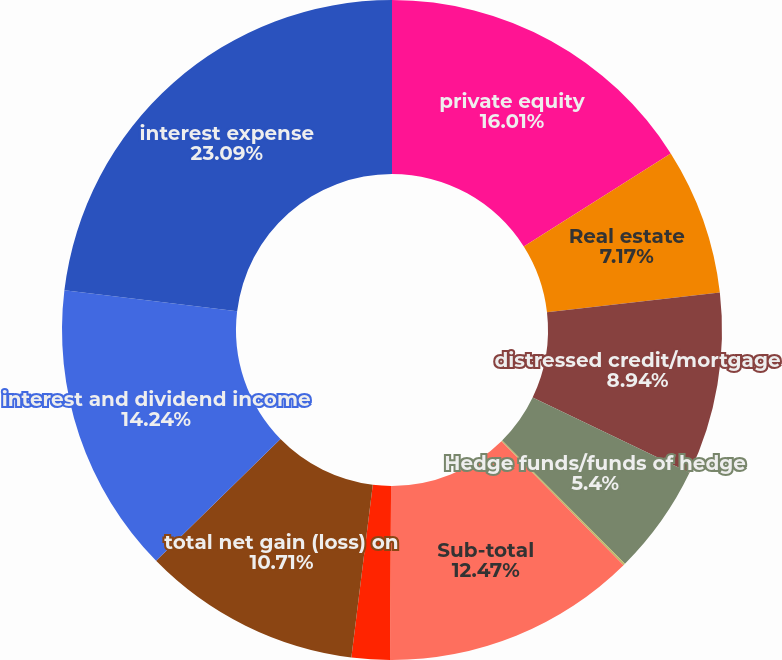<chart> <loc_0><loc_0><loc_500><loc_500><pie_chart><fcel>private equity<fcel>Real estate<fcel>distressed credit/mortgage<fcel>Hedge funds/funds of hedge<fcel>Other investments (2)<fcel>Sub-total<fcel>investments related to<fcel>total net gain (loss) on<fcel>interest and dividend income<fcel>interest expense<nl><fcel>16.01%<fcel>7.17%<fcel>8.94%<fcel>5.4%<fcel>0.1%<fcel>12.47%<fcel>1.87%<fcel>10.71%<fcel>14.24%<fcel>23.08%<nl></chart> 